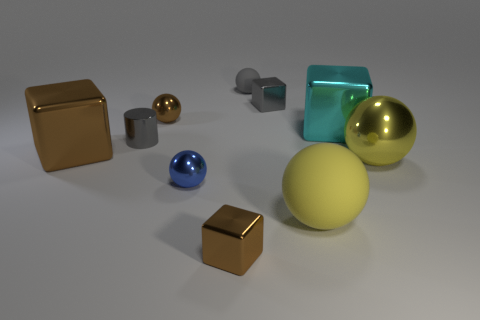Subtract all tiny gray rubber balls. How many balls are left? 4 Subtract all yellow balls. How many brown blocks are left? 2 Subtract all yellow spheres. How many spheres are left? 3 Subtract all blocks. How many objects are left? 6 Subtract 0 cyan cylinders. How many objects are left? 10 Subtract 2 balls. How many balls are left? 3 Subtract all green cylinders. Subtract all gray balls. How many cylinders are left? 1 Subtract all big matte spheres. Subtract all tiny brown shiny things. How many objects are left? 7 Add 3 tiny blue metallic things. How many tiny blue metallic things are left? 4 Add 4 blue shiny balls. How many blue shiny balls exist? 5 